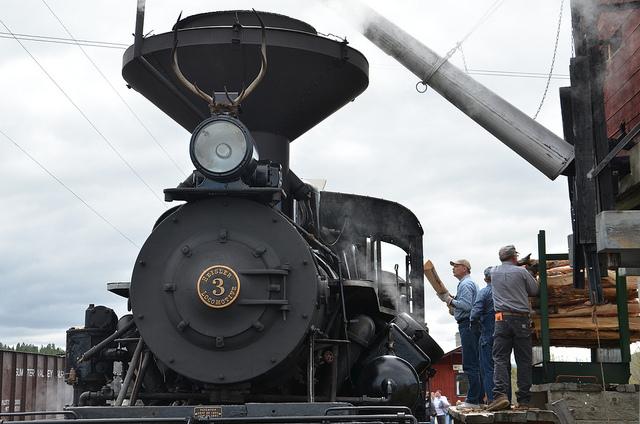What are the men loading into the train?
Be succinct. Wood. What color is the train?
Be succinct. Black. What is the number on the train?
Give a very brief answer. 3. What number is in front of the train?
Keep it brief. 3. 